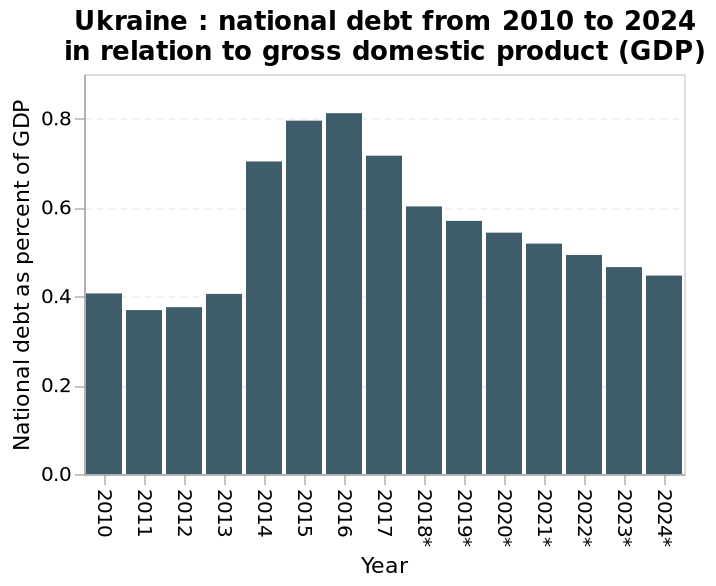<image>
please enumerates aspects of the construction of the chart Ukraine : national debt from 2010 to 2024 in relation to gross domestic product (GDP) is a bar graph. The y-axis plots National debt as percent of GDP with linear scale with a minimum of 0.0 and a maximum of 0.8 while the x-axis measures Year on categorical scale starting with 2010 and ending with 2024*. What does the x-axis of the bar graph represent in the context of Ukraine's national debt? The x-axis of the bar graph represents the years from 2010 to 2024, indicating the timeline for the national debt data. please summary the statistics and relations of the chart The year 2016 saw the largest debt for Ukraine. There is a large jump in national debt from 2013 to 2014. 